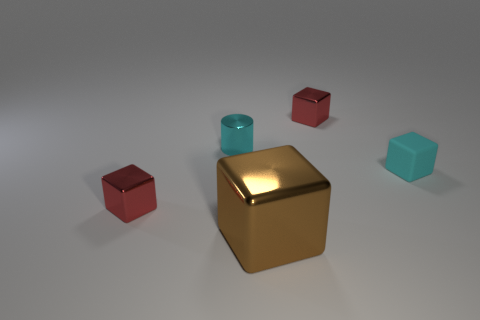Subtract all small cyan matte cubes. How many cubes are left? 3 Subtract all purple spheres. How many red cubes are left? 2 Subtract all brown blocks. How many blocks are left? 3 Subtract 2 blocks. How many blocks are left? 2 Subtract all purple blocks. Subtract all purple spheres. How many blocks are left? 4 Add 1 large green matte cylinders. How many objects exist? 6 Subtract all cylinders. How many objects are left? 4 Add 4 red metallic objects. How many red metallic objects are left? 6 Add 1 small yellow metallic objects. How many small yellow metallic objects exist? 1 Subtract 1 brown cubes. How many objects are left? 4 